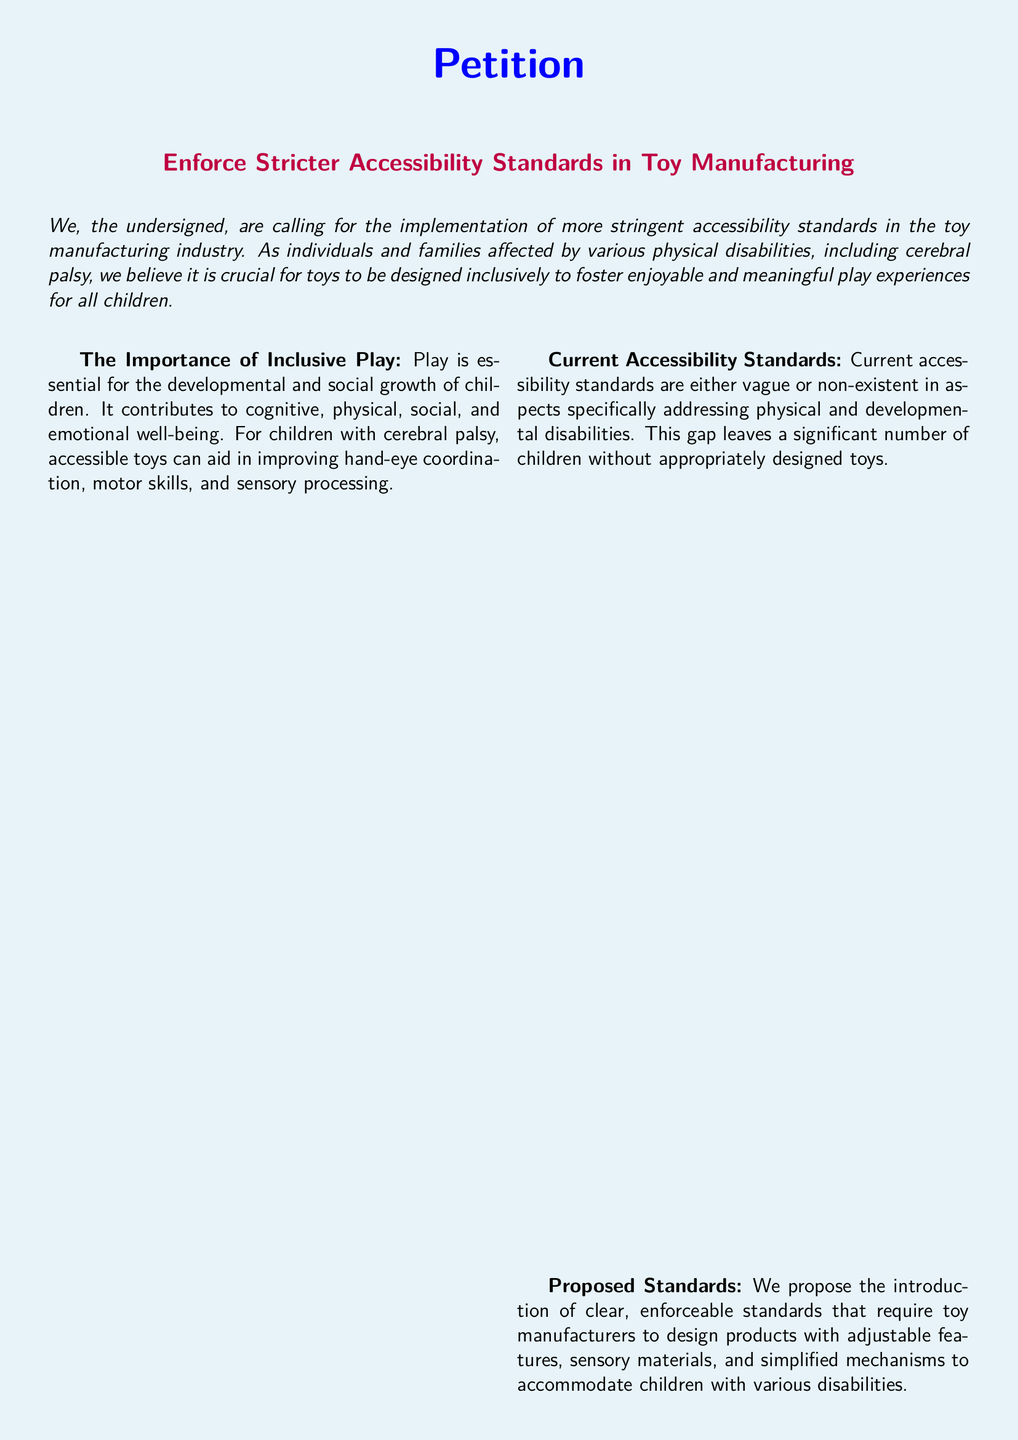What is the title of the petition? The title of the petition is stated prominently and details the aim of the petition.
Answer: Enforce Stricter Accessibility Standards in Toy Manufacturing Who is the petition addressed to? The petition does not specify a recipient, but it urges various stakeholders and policymakers to take action.
Answer: Industry leaders, policymakers, and stakeholders What is mentioned as a benefit of inclusive toys? The document lists the benefits of inclusive toys, which contribute to various aspects of child development.
Answer: Social impacts What are proposed standards supposed to include? The proposed standards are outlined to ensure that toys are designed properly for children with disabilities.
Answer: Adjustable features, sensory materials, and simplified mechanisms How many columns are used in the document? The document presents information in multiple columns to organize content effectively.
Answer: Two What is the document's primary focus? The primary focus of the document is expressed in the introduction, emphasizing the need for change.
Answer: Accessibility standards What color is used for the page background? The document uses a specific color for enhancing the visual appeal of the content.
Answer: Light blue What is the purpose of signing the petition? Signing the petition signifies support for the cause stated in the document.
Answer: Support inclusive play What kind of materials are advocated for in toys? The petition highlights the importance of specific materials in enhancing play for children with disabilities.
Answer: Sensory materials 